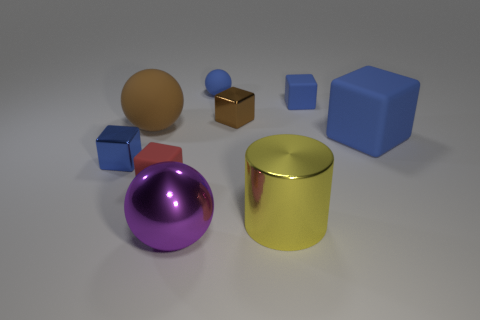How many blue blocks must be subtracted to get 1 blue blocks? 2 Subtract all cyan cylinders. How many blue blocks are left? 3 Subtract 1 blocks. How many blocks are left? 4 Subtract all brown shiny cubes. How many cubes are left? 4 Subtract all red cubes. How many cubes are left? 4 Subtract all yellow blocks. Subtract all brown balls. How many blocks are left? 5 Subtract all cubes. How many objects are left? 4 Add 8 red blocks. How many red blocks exist? 9 Subtract 0 brown cylinders. How many objects are left? 9 Subtract all blue matte cylinders. Subtract all big metal spheres. How many objects are left? 8 